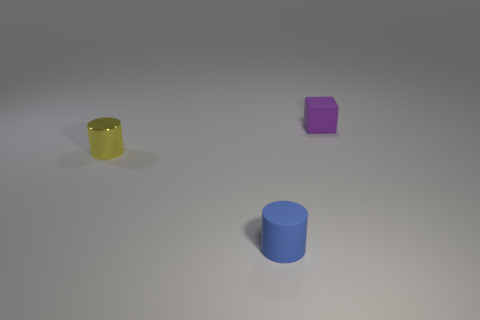Add 3 purple rubber things. How many objects exist? 6 Subtract 0 brown spheres. How many objects are left? 3 Subtract all cylinders. How many objects are left? 1 Subtract 1 cylinders. How many cylinders are left? 1 Subtract all blue cubes. Subtract all brown cylinders. How many cubes are left? 1 Subtract all green cubes. How many blue cylinders are left? 1 Subtract all blue matte cubes. Subtract all small yellow things. How many objects are left? 2 Add 1 yellow shiny objects. How many yellow shiny objects are left? 2 Add 2 blue matte cylinders. How many blue matte cylinders exist? 3 Subtract all yellow cylinders. How many cylinders are left? 1 